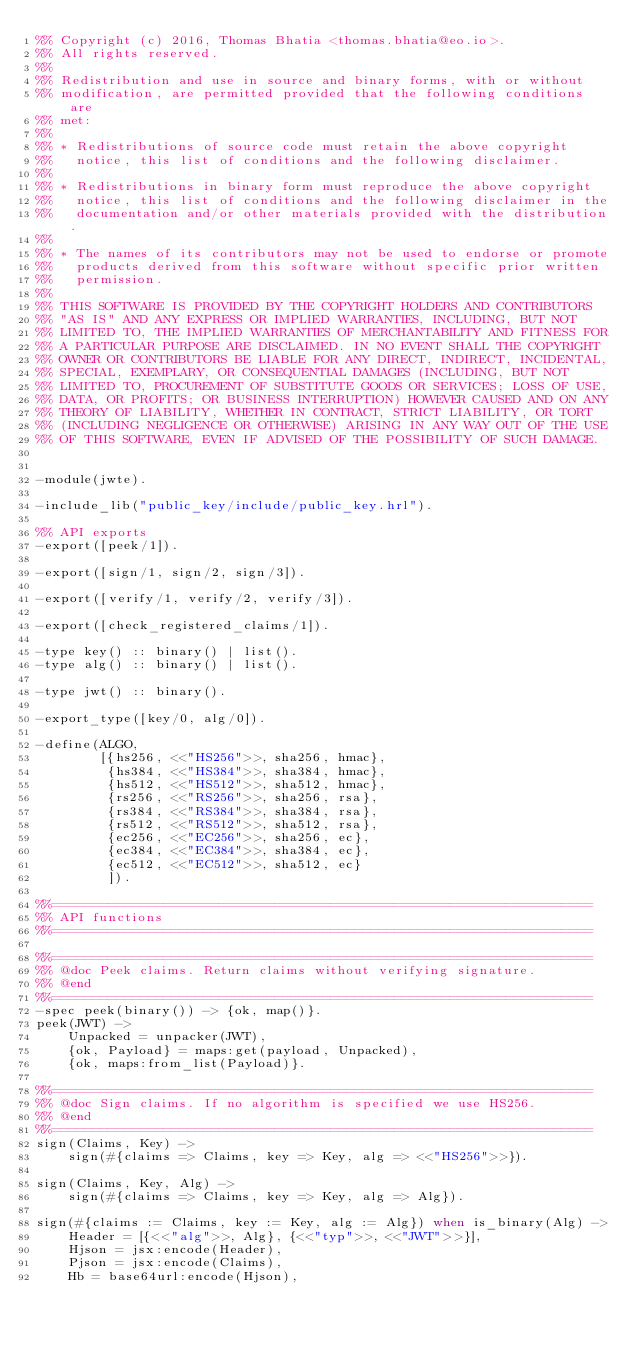Convert code to text. <code><loc_0><loc_0><loc_500><loc_500><_Erlang_>%% Copyright (c) 2016, Thomas Bhatia <thomas.bhatia@eo.io>.
%% All rights reserved.
%%
%% Redistribution and use in source and binary forms, with or without
%% modification, are permitted provided that the following conditions are
%% met:
%%
%% * Redistributions of source code must retain the above copyright
%%   notice, this list of conditions and the following disclaimer.
%%
%% * Redistributions in binary form must reproduce the above copyright
%%   notice, this list of conditions and the following disclaimer in the
%%   documentation and/or other materials provided with the distribution.
%%
%% * The names of its contributors may not be used to endorse or promote
%%   products derived from this software without specific prior written
%%   permission.
%%
%% THIS SOFTWARE IS PROVIDED BY THE COPYRIGHT HOLDERS AND CONTRIBUTORS
%% "AS IS" AND ANY EXPRESS OR IMPLIED WARRANTIES, INCLUDING, BUT NOT
%% LIMITED TO, THE IMPLIED WARRANTIES OF MERCHANTABILITY AND FITNESS FOR
%% A PARTICULAR PURPOSE ARE DISCLAIMED. IN NO EVENT SHALL THE COPYRIGHT
%% OWNER OR CONTRIBUTORS BE LIABLE FOR ANY DIRECT, INDIRECT, INCIDENTAL,
%% SPECIAL, EXEMPLARY, OR CONSEQUENTIAL DAMAGES (INCLUDING, BUT NOT
%% LIMITED TO, PROCUREMENT OF SUBSTITUTE GOODS OR SERVICES; LOSS OF USE,
%% DATA, OR PROFITS; OR BUSINESS INTERRUPTION) HOWEVER CAUSED AND ON ANY
%% THEORY OF LIABILITY, WHETHER IN CONTRACT, STRICT LIABILITY, OR TORT
%% (INCLUDING NEGLIGENCE OR OTHERWISE) ARISING IN ANY WAY OUT OF THE USE
%% OF THIS SOFTWARE, EVEN IF ADVISED OF THE POSSIBILITY OF SUCH DAMAGE.


-module(jwte).

-include_lib("public_key/include/public_key.hrl").

%% API exports
-export([peek/1]).

-export([sign/1, sign/2, sign/3]).

-export([verify/1, verify/2, verify/3]).

-export([check_registered_claims/1]).

-type key() :: binary() | list().
-type alg() :: binary() | list().

-type jwt() :: binary().

-export_type([key/0, alg/0]).

-define(ALGO,
        [{hs256, <<"HS256">>, sha256, hmac},
         {hs384, <<"HS384">>, sha384, hmac},
         {hs512, <<"HS512">>, sha512, hmac},
         {rs256, <<"RS256">>, sha256, rsa},
         {rs384, <<"RS384">>, sha384, rsa},
         {rs512, <<"RS512">>, sha512, rsa},
         {ec256, <<"EC256">>, sha256, ec},
         {ec384, <<"EC384">>, sha384, ec},
         {ec512, <<"EC512">>, sha512, ec}
         ]).

%%====================================================================
%% API functions
%%====================================================================

%%====================================================================
%% @doc Peek claims. Return claims without verifying signature.
%% @end
%%====================================================================
-spec peek(binary()) -> {ok, map()}.
peek(JWT) ->
    Unpacked = unpacker(JWT),
    {ok, Payload} = maps:get(payload, Unpacked),
    {ok, maps:from_list(Payload)}.

%%====================================================================
%% @doc Sign claims. If no algorithm is specified we use HS256.
%% @end
%%====================================================================
sign(Claims, Key) ->
    sign(#{claims => Claims, key => Key, alg => <<"HS256">>}).

sign(Claims, Key, Alg) ->
    sign(#{claims => Claims, key => Key, alg => Alg}).

sign(#{claims := Claims, key := Key, alg := Alg}) when is_binary(Alg) ->
    Header = [{<<"alg">>, Alg}, {<<"typ">>, <<"JWT">>}],
    Hjson = jsx:encode(Header),
    Pjson = jsx:encode(Claims),
    Hb = base64url:encode(Hjson),</code> 